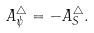Convert formula to latex. <formula><loc_0><loc_0><loc_500><loc_500>A ^ { \triangle } _ { \psi } = - A ^ { \triangle } _ { S } .</formula> 